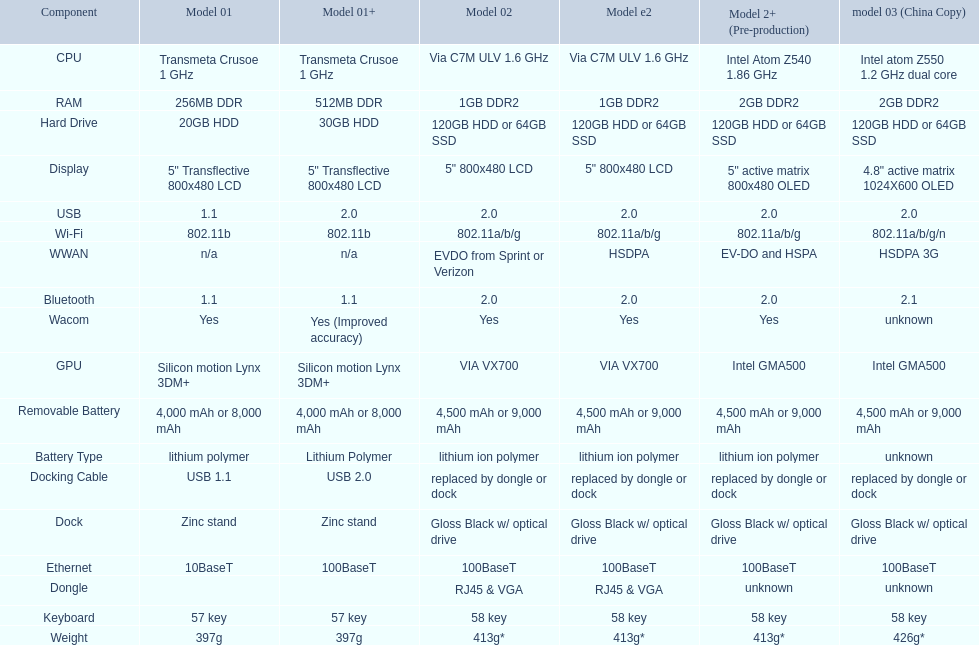Which hard drive model has a higher capacity than the 30gb one? 64GB SSD. Would you mind parsing the complete table? {'header': ['Component', 'Model 01', 'Model 01+', 'Model 02', 'Model e2', 'Model 2+ (Pre-production)', 'model 03 (China Copy)'], 'rows': [['CPU', 'Transmeta Crusoe 1\xa0GHz', 'Transmeta Crusoe 1\xa0GHz', 'Via C7M ULV 1.6\xa0GHz', 'Via C7M ULV 1.6\xa0GHz', 'Intel Atom Z540 1.86\xa0GHz', 'Intel atom Z550 1.2\xa0GHz dual core'], ['RAM', '256MB DDR', '512MB DDR', '1GB DDR2', '1GB DDR2', '2GB DDR2', '2GB DDR2'], ['Hard Drive', '20GB HDD', '30GB HDD', '120GB HDD or 64GB SSD', '120GB HDD or 64GB SSD', '120GB HDD or 64GB SSD', '120GB HDD or 64GB SSD'], ['Display', '5" Transflective 800x480 LCD', '5" Transflective 800x480 LCD', '5" 800x480 LCD', '5" 800x480 LCD', '5" active matrix 800x480 OLED', '4.8" active matrix 1024X600 OLED'], ['USB', '1.1', '2.0', '2.0', '2.0', '2.0', '2.0'], ['Wi-Fi', '802.11b', '802.11b', '802.11a/b/g', '802.11a/b/g', '802.11a/b/g', '802.11a/b/g/n'], ['WWAN', 'n/a', 'n/a', 'EVDO from Sprint or Verizon', 'HSDPA', 'EV-DO and HSPA', 'HSDPA 3G'], ['Bluetooth', '1.1', '1.1', '2.0', '2.0', '2.0', '2.1'], ['Wacom', 'Yes', 'Yes (Improved accuracy)', 'Yes', 'Yes', 'Yes', 'unknown'], ['GPU', 'Silicon motion Lynx 3DM+', 'Silicon motion Lynx 3DM+', 'VIA VX700', 'VIA VX700', 'Intel GMA500', 'Intel GMA500'], ['Removable Battery', '4,000 mAh or 8,000 mAh', '4,000 mAh or 8,000 mAh', '4,500 mAh or 9,000 mAh', '4,500 mAh or 9,000 mAh', '4,500 mAh or 9,000 mAh', '4,500 mAh or 9,000 mAh'], ['Battery Type', 'lithium polymer', 'Lithium Polymer', 'lithium ion polymer', 'lithium ion polymer', 'lithium ion polymer', 'unknown'], ['Docking Cable', 'USB 1.1', 'USB 2.0', 'replaced by dongle or dock', 'replaced by dongle or dock', 'replaced by dongle or dock', 'replaced by dongle or dock'], ['Dock', 'Zinc stand', 'Zinc stand', 'Gloss Black w/ optical drive', 'Gloss Black w/ optical drive', 'Gloss Black w/ optical drive', 'Gloss Black w/ optical drive'], ['Ethernet', '10BaseT', '100BaseT', '100BaseT', '100BaseT', '100BaseT', '100BaseT'], ['Dongle', '', '', 'RJ45 & VGA', 'RJ45 & VGA', 'unknown', 'unknown'], ['Keyboard', '57 key', '57 key', '58 key', '58 key', '58 key', '58 key'], ['Weight', '397g', '397g', '413g*', '413g*', '413g*', '426g*']]} 